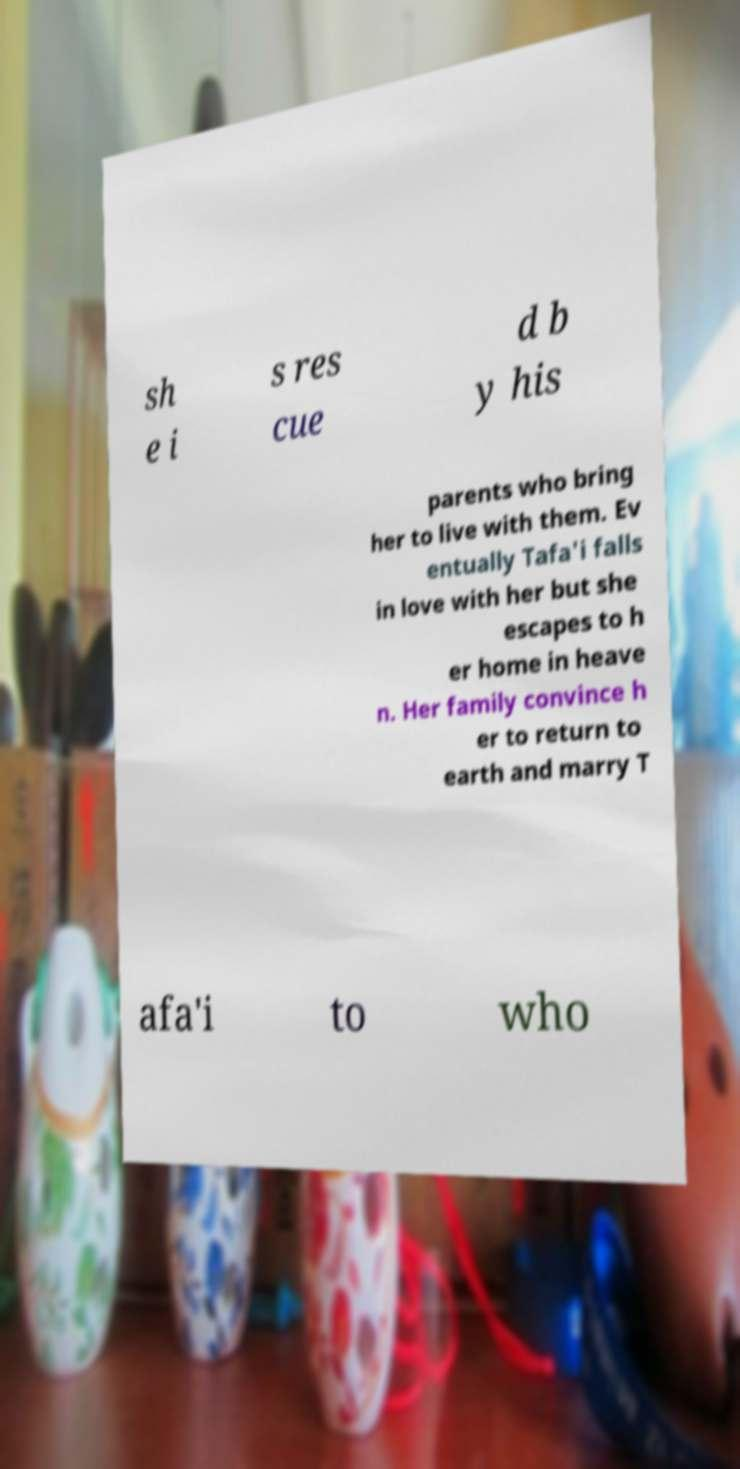I need the written content from this picture converted into text. Can you do that? sh e i s res cue d b y his parents who bring her to live with them. Ev entually Tafa'i falls in love with her but she escapes to h er home in heave n. Her family convince h er to return to earth and marry T afa'i to who 